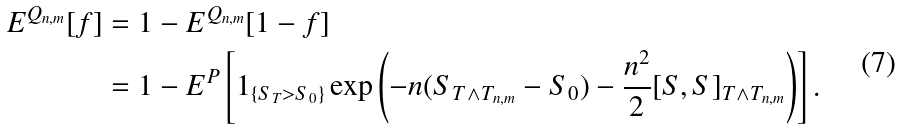Convert formula to latex. <formula><loc_0><loc_0><loc_500><loc_500>E ^ { Q _ { n , m } } [ f ] & = 1 - E ^ { Q _ { n , m } } [ 1 - f ] \\ & = 1 - E ^ { P } \left [ 1 _ { \{ S _ { T } > S _ { 0 } \} } \exp \left ( - n ( S _ { T \wedge T _ { n , m } } - S _ { 0 } ) - \frac { n ^ { 2 } } { 2 } [ S , S ] _ { T \wedge T _ { n , m } } \right ) \right ] .</formula> 